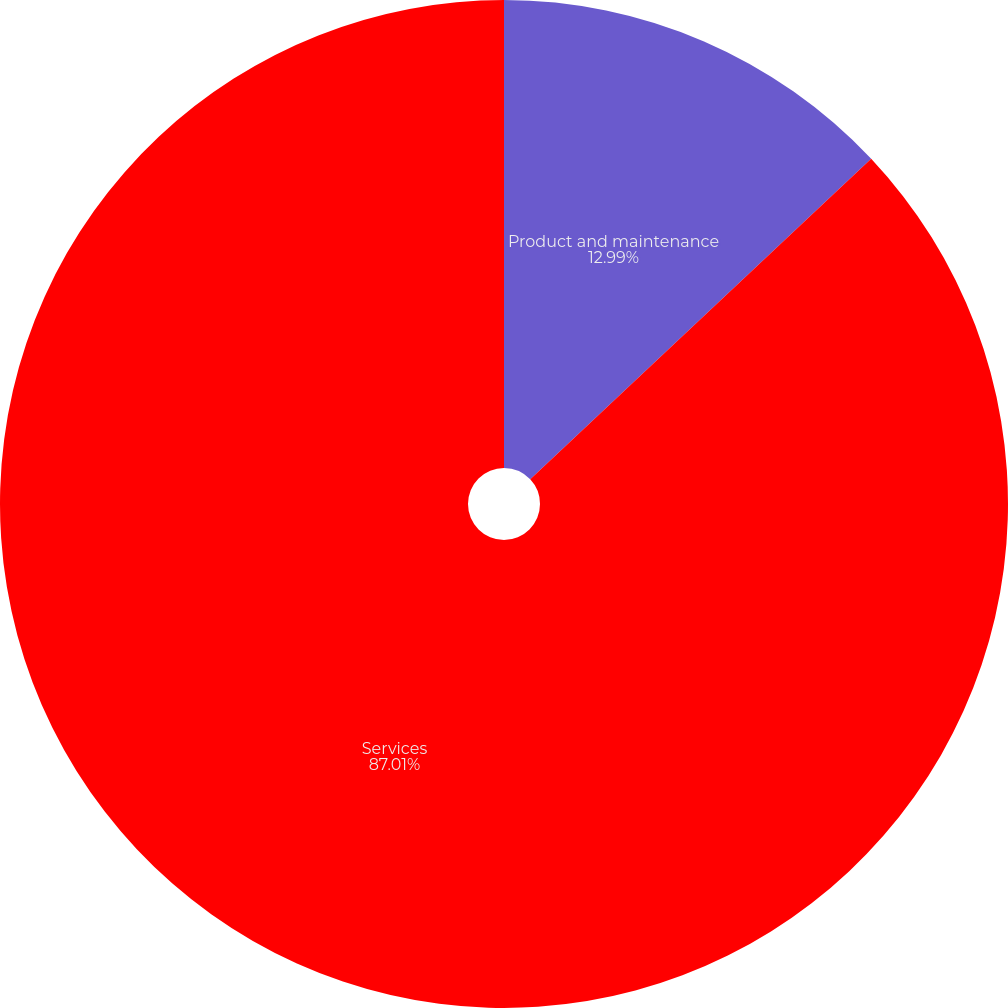Convert chart. <chart><loc_0><loc_0><loc_500><loc_500><pie_chart><fcel>Product and maintenance<fcel>Services<nl><fcel>12.99%<fcel>87.01%<nl></chart> 